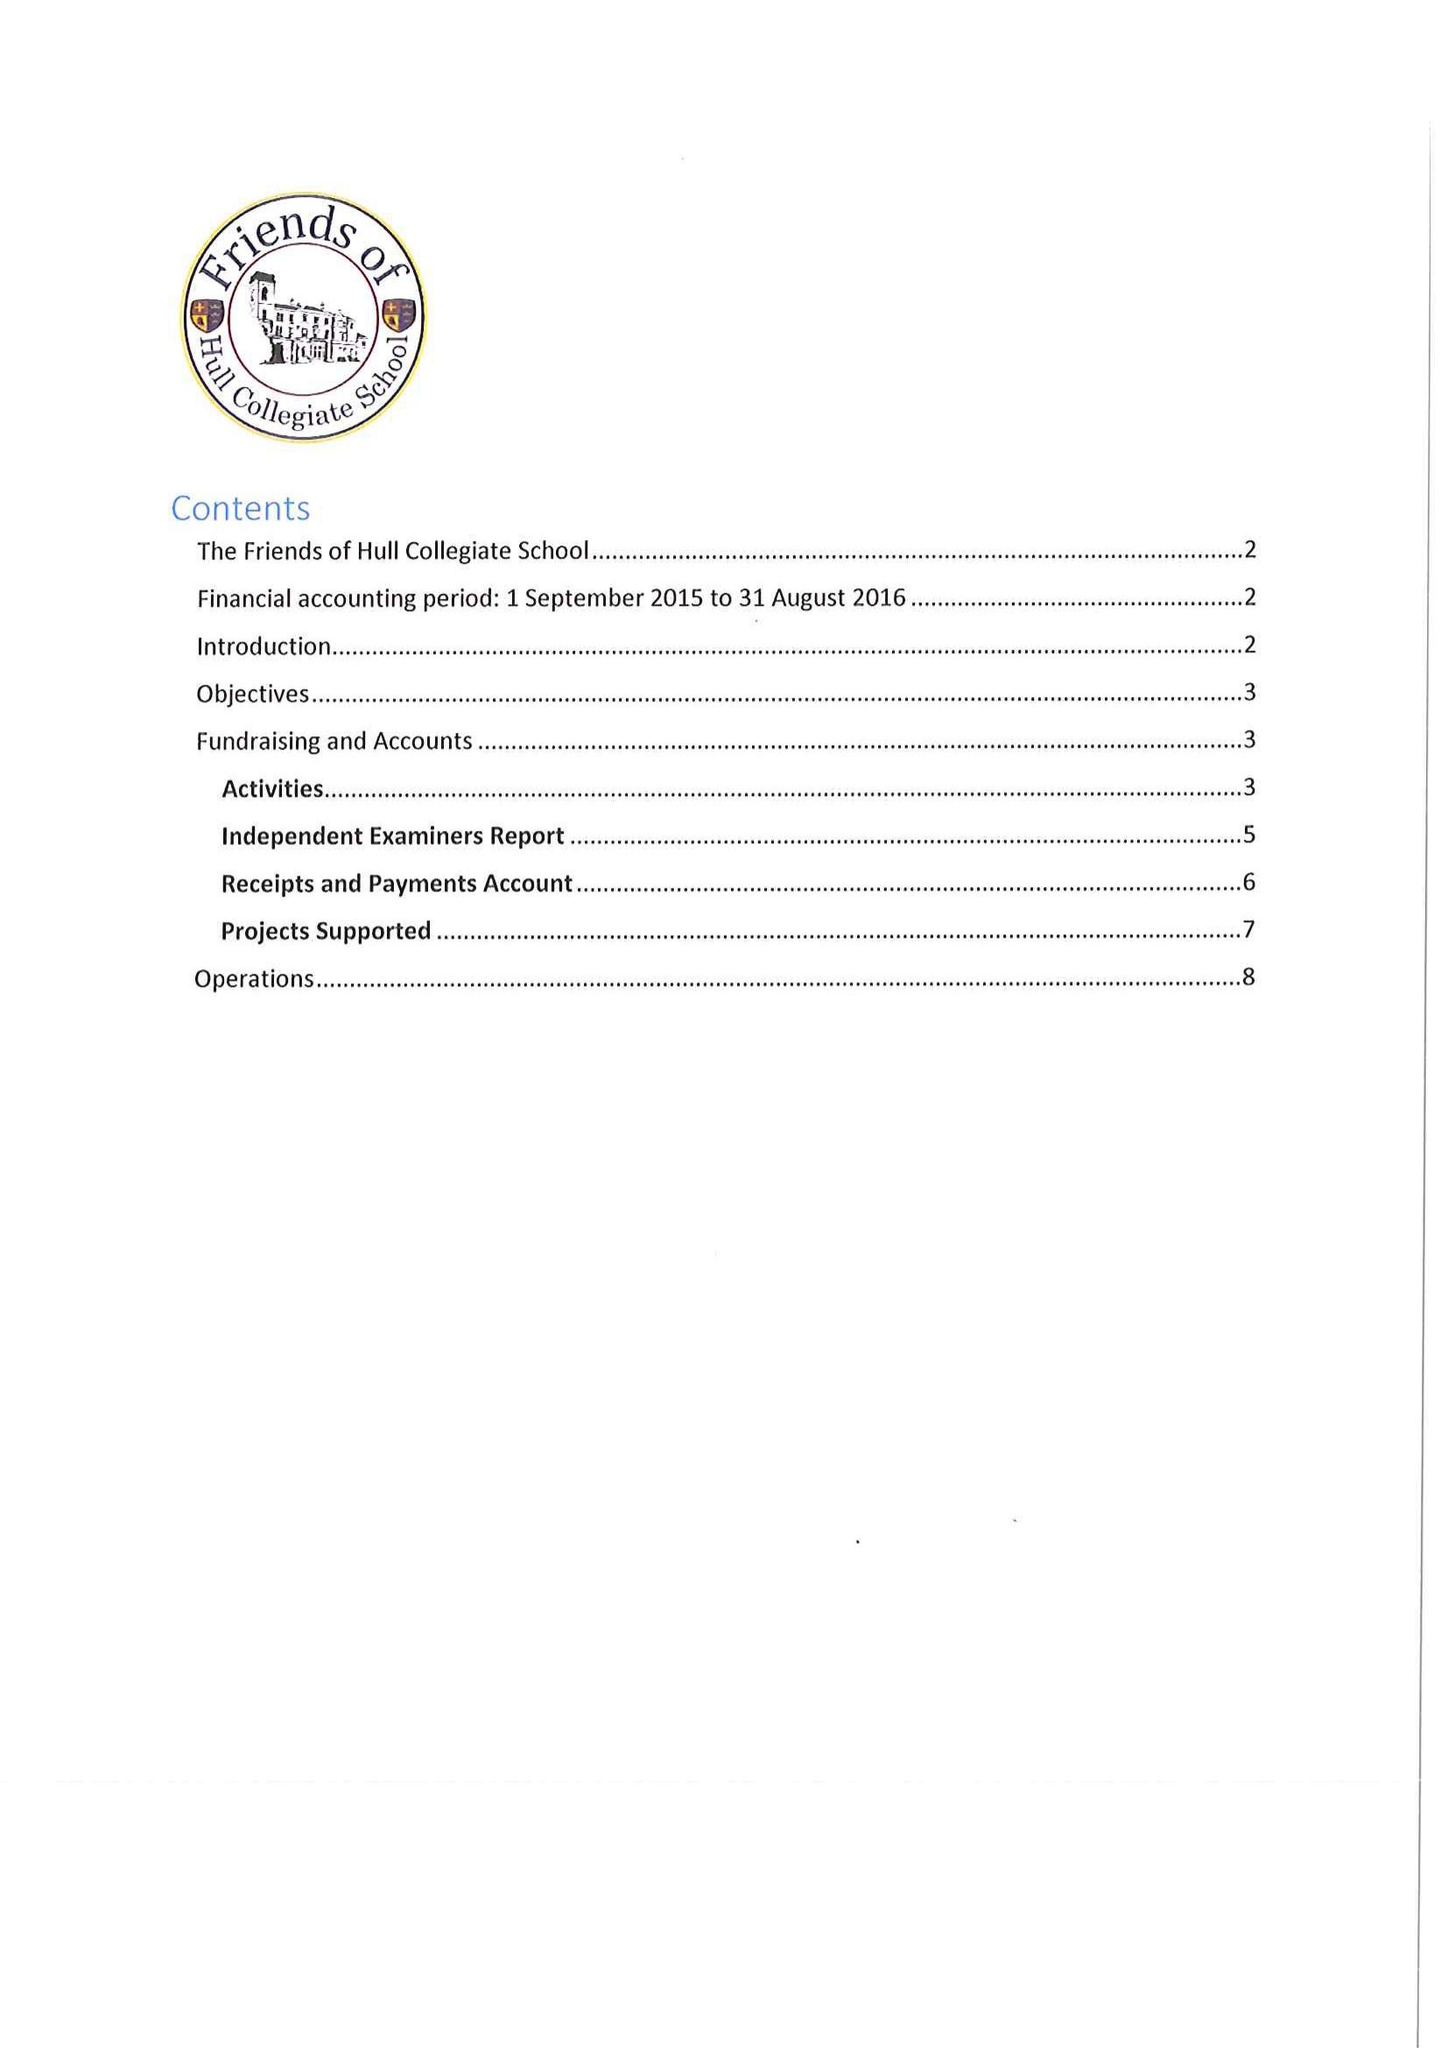What is the value for the address__post_town?
Answer the question using a single word or phrase. HULL 